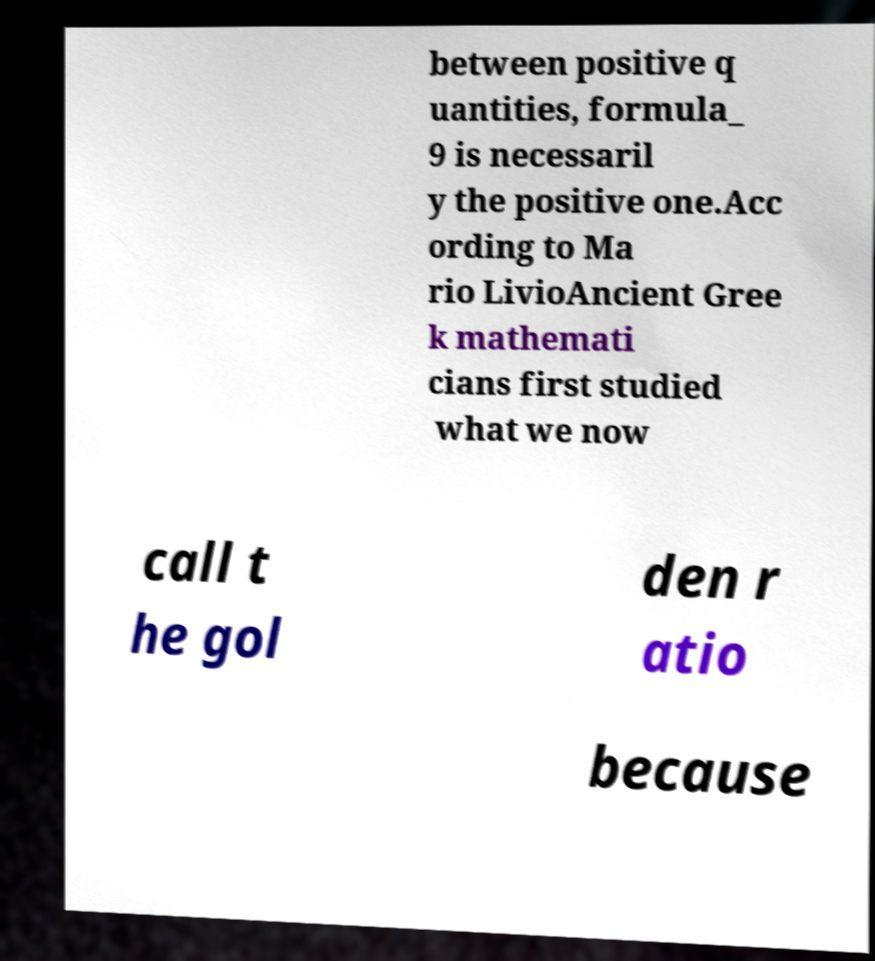Can you read and provide the text displayed in the image?This photo seems to have some interesting text. Can you extract and type it out for me? between positive q uantities, formula_ 9 is necessaril y the positive one.Acc ording to Ma rio LivioAncient Gree k mathemati cians first studied what we now call t he gol den r atio because 